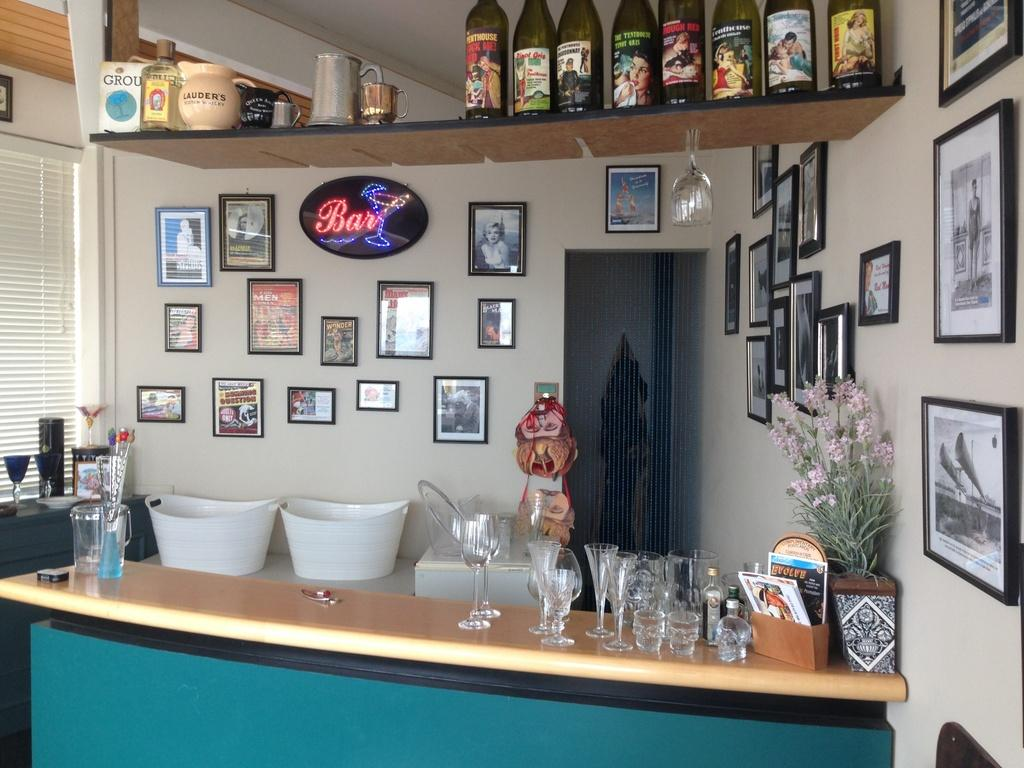<image>
Share a concise interpretation of the image provided. Store front that has a light up sign that says Bar. 